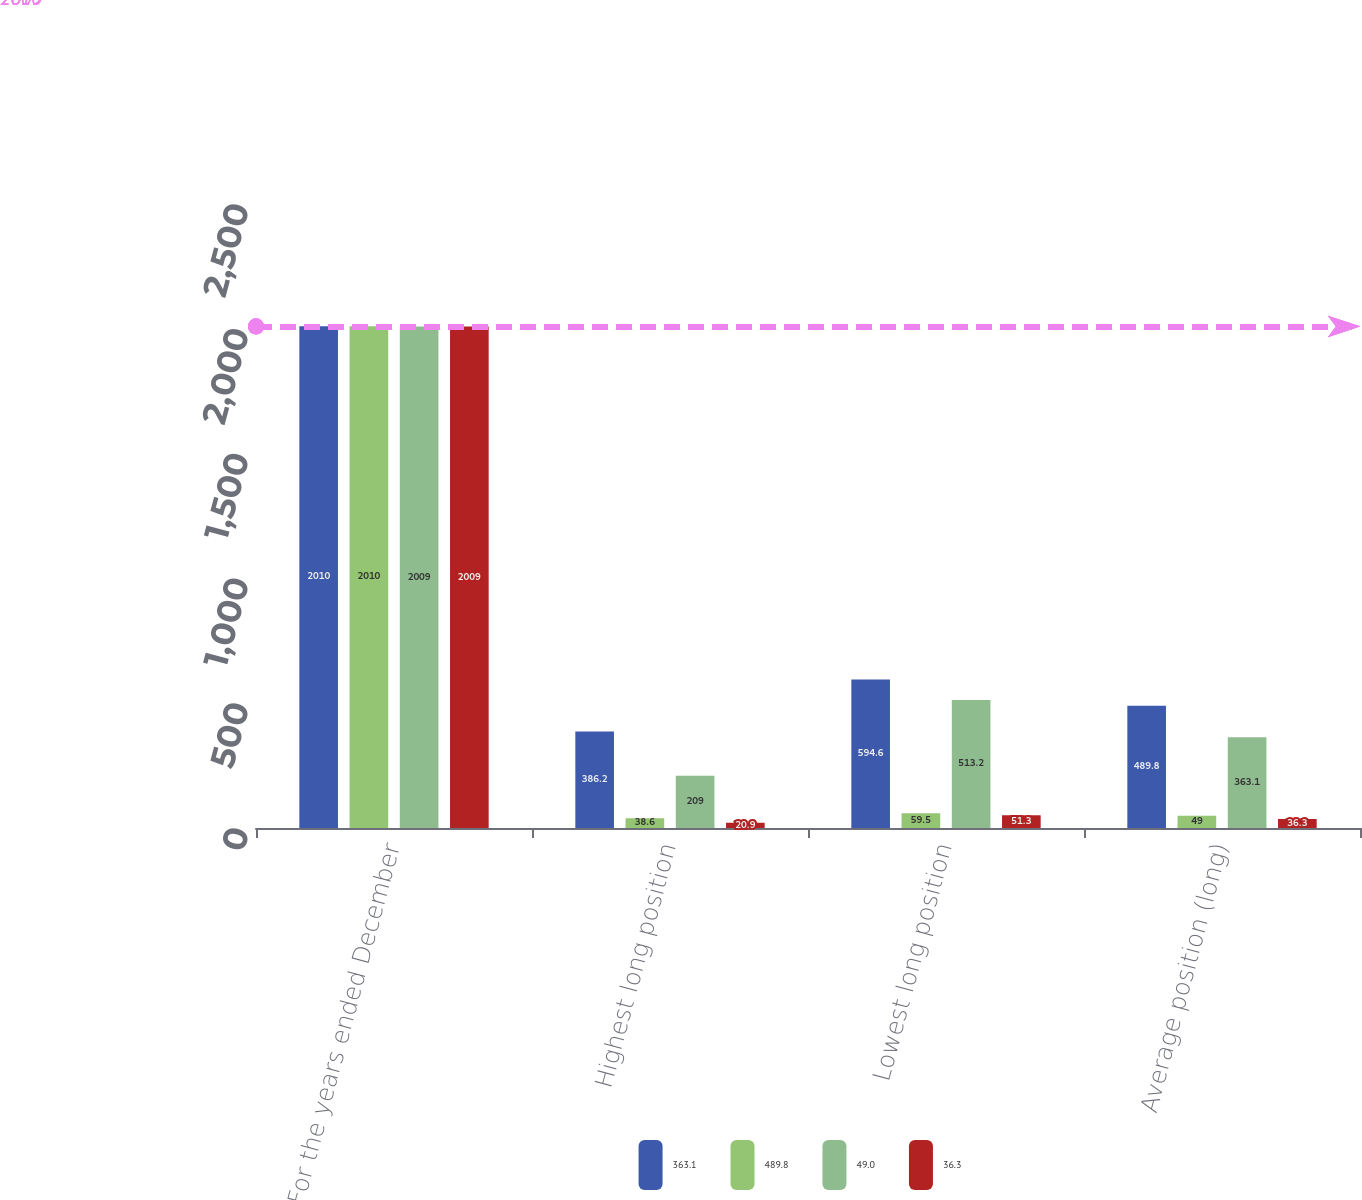<chart> <loc_0><loc_0><loc_500><loc_500><stacked_bar_chart><ecel><fcel>For the years ended December<fcel>Highest long position<fcel>Lowest long position<fcel>Average position (long)<nl><fcel>363.1<fcel>2010<fcel>386.2<fcel>594.6<fcel>489.8<nl><fcel>489.8<fcel>2010<fcel>38.6<fcel>59.5<fcel>49<nl><fcel>49<fcel>2009<fcel>209<fcel>513.2<fcel>363.1<nl><fcel>36.3<fcel>2009<fcel>20.9<fcel>51.3<fcel>36.3<nl></chart> 